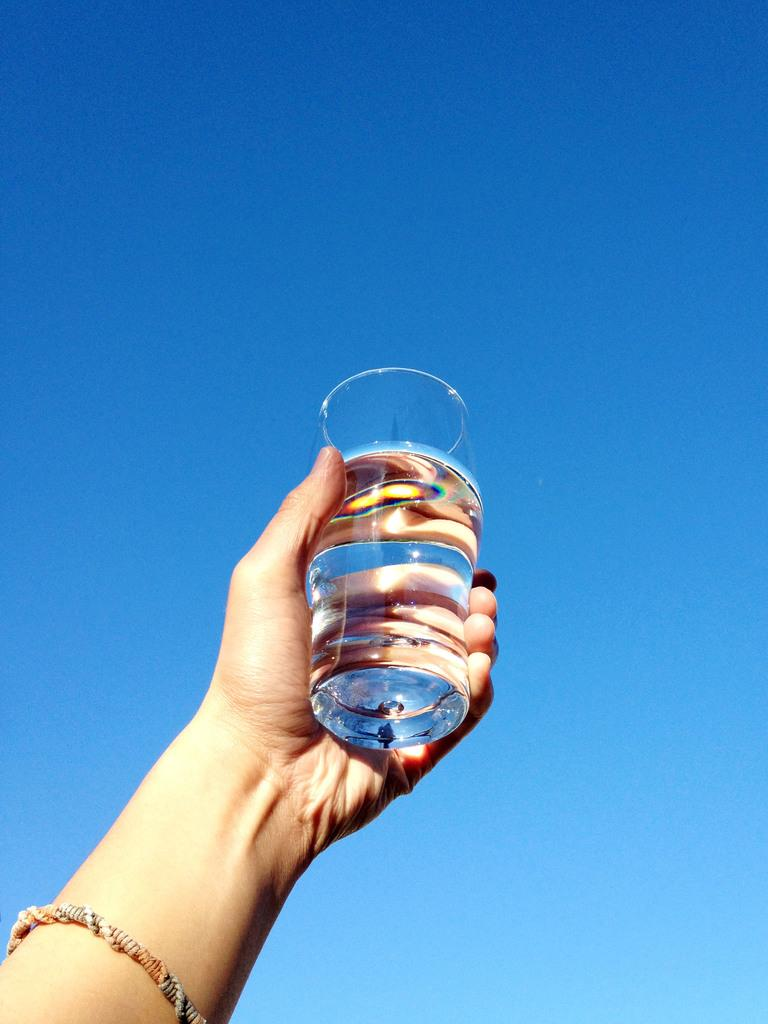What can be seen in the image related to a person's hand? There is a person's hand in the image, and it is holding a glass. What is the hand holding in the image? The hand is holding a glass. What can be seen in the background of the image? The sky is visible in the background of the image. How many pets can be seen in the image? There are no pets visible in the image. Are there any bikes present in the image? There is no mention of bikes in the provided facts, and therefore we cannot determine if any are present in the image. What is the mass of the glass being held in the image? The mass of the glass cannot be determined from the image alone, as it would require additional information or tools to measure. 